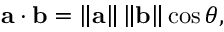Convert formula to latex. <formula><loc_0><loc_0><loc_500><loc_500>a \cdot b = \left \| a \right \| \left \| b \right \| \cos \theta ,</formula> 